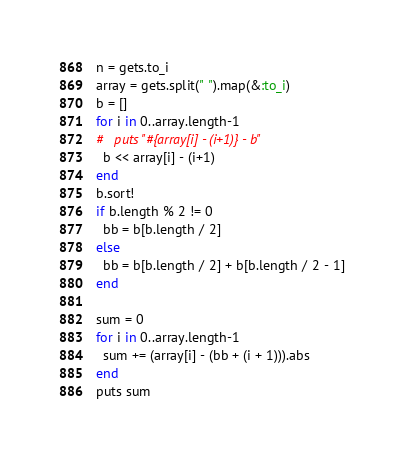Convert code to text. <code><loc_0><loc_0><loc_500><loc_500><_Ruby_>n = gets.to_i
array = gets.split(" ").map(&:to_i)
b = []
for i in 0..array.length-1
#   puts "#{array[i] - (i+1)} - b"
  b << array[i] - (i+1)
end
b.sort!
if b.length % 2 != 0
  bb = b[b.length / 2]
else
  bb = b[b.length / 2] + b[b.length / 2 - 1]
end

sum = 0
for i in 0..array.length-1
  sum += (array[i] - (bb + (i + 1))).abs
end
puts sum</code> 